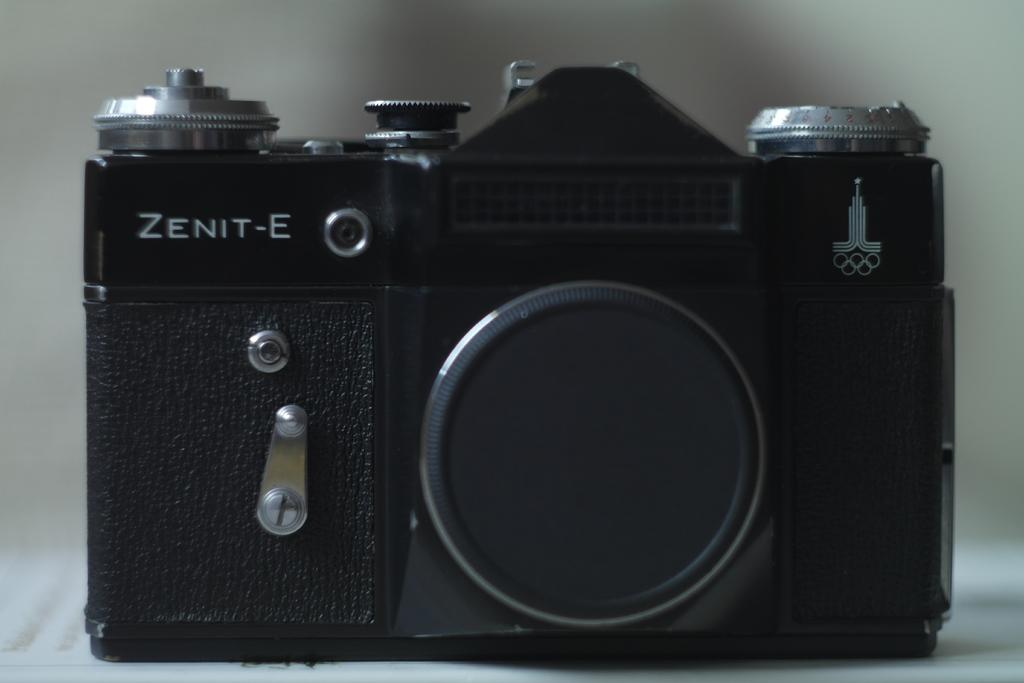What type of object is the main subject of the image? There is a black color camera in the image. Can you describe the camera in the image? The camera is black in color. What type of fruit is hanging from the camera in the image? There is no fruit hanging from the camera in the image. 